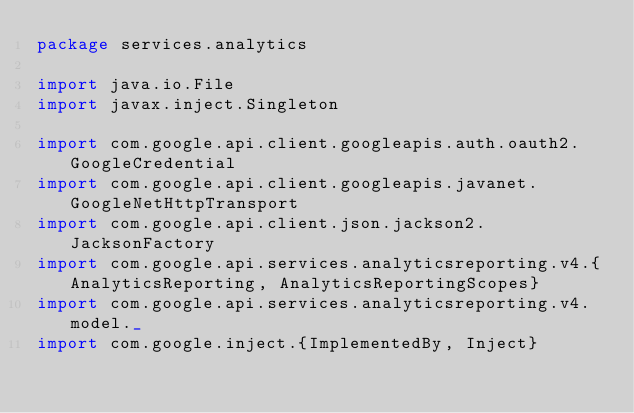Convert code to text. <code><loc_0><loc_0><loc_500><loc_500><_Scala_>package services.analytics

import java.io.File
import javax.inject.Singleton

import com.google.api.client.googleapis.auth.oauth2.GoogleCredential
import com.google.api.client.googleapis.javanet.GoogleNetHttpTransport
import com.google.api.client.json.jackson2.JacksonFactory
import com.google.api.services.analyticsreporting.v4.{AnalyticsReporting, AnalyticsReportingScopes}
import com.google.api.services.analyticsreporting.v4.model._
import com.google.inject.{ImplementedBy, Inject}</code> 